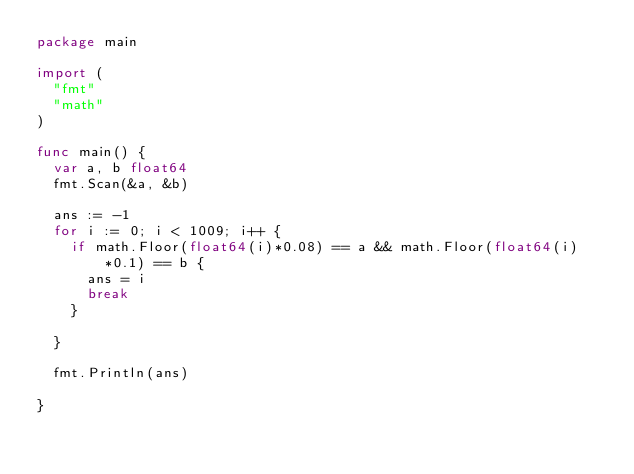<code> <loc_0><loc_0><loc_500><loc_500><_Go_>package main

import (
	"fmt"
	"math"
)

func main() {
	var a, b float64
	fmt.Scan(&a, &b)

	ans := -1
	for i := 0; i < 1009; i++ {
		if math.Floor(float64(i)*0.08) == a && math.Floor(float64(i)*0.1) == b {
			ans = i
			break
		}

	}

	fmt.Println(ans)

}
</code> 